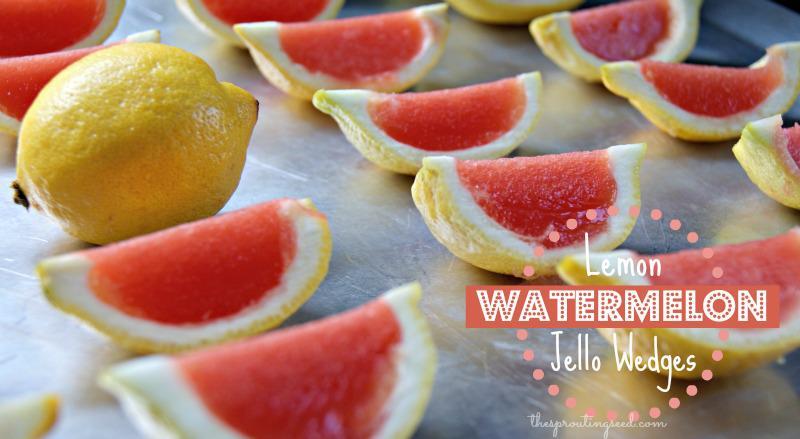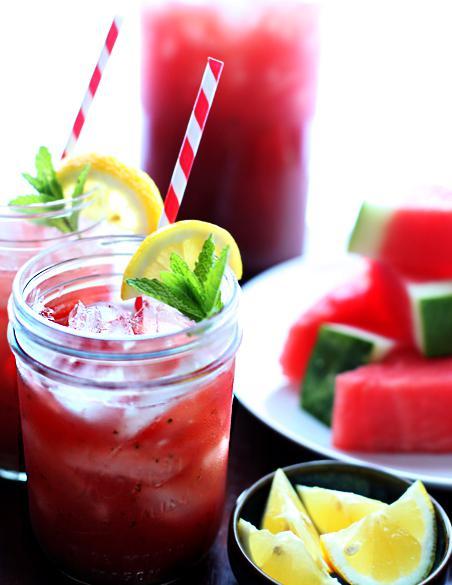The first image is the image on the left, the second image is the image on the right. Considering the images on both sides, is "Each of the images features fresh watermelon slices along with popsicles." valid? Answer yes or no. No. 